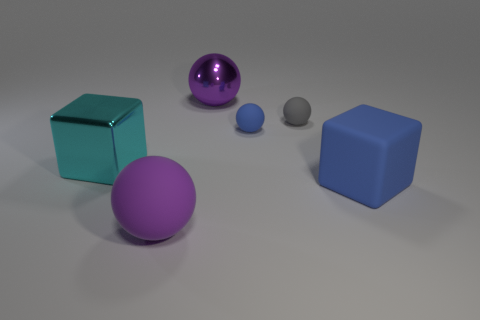Subtract 1 spheres. How many spheres are left? 3 Subtract all yellow spheres. Subtract all green cylinders. How many spheres are left? 4 Add 1 large rubber things. How many objects exist? 7 Subtract all balls. How many objects are left? 2 Add 5 tiny rubber balls. How many tiny rubber balls are left? 7 Add 2 matte cubes. How many matte cubes exist? 3 Subtract 0 gray blocks. How many objects are left? 6 Subtract all small blue shiny blocks. Subtract all blue spheres. How many objects are left? 5 